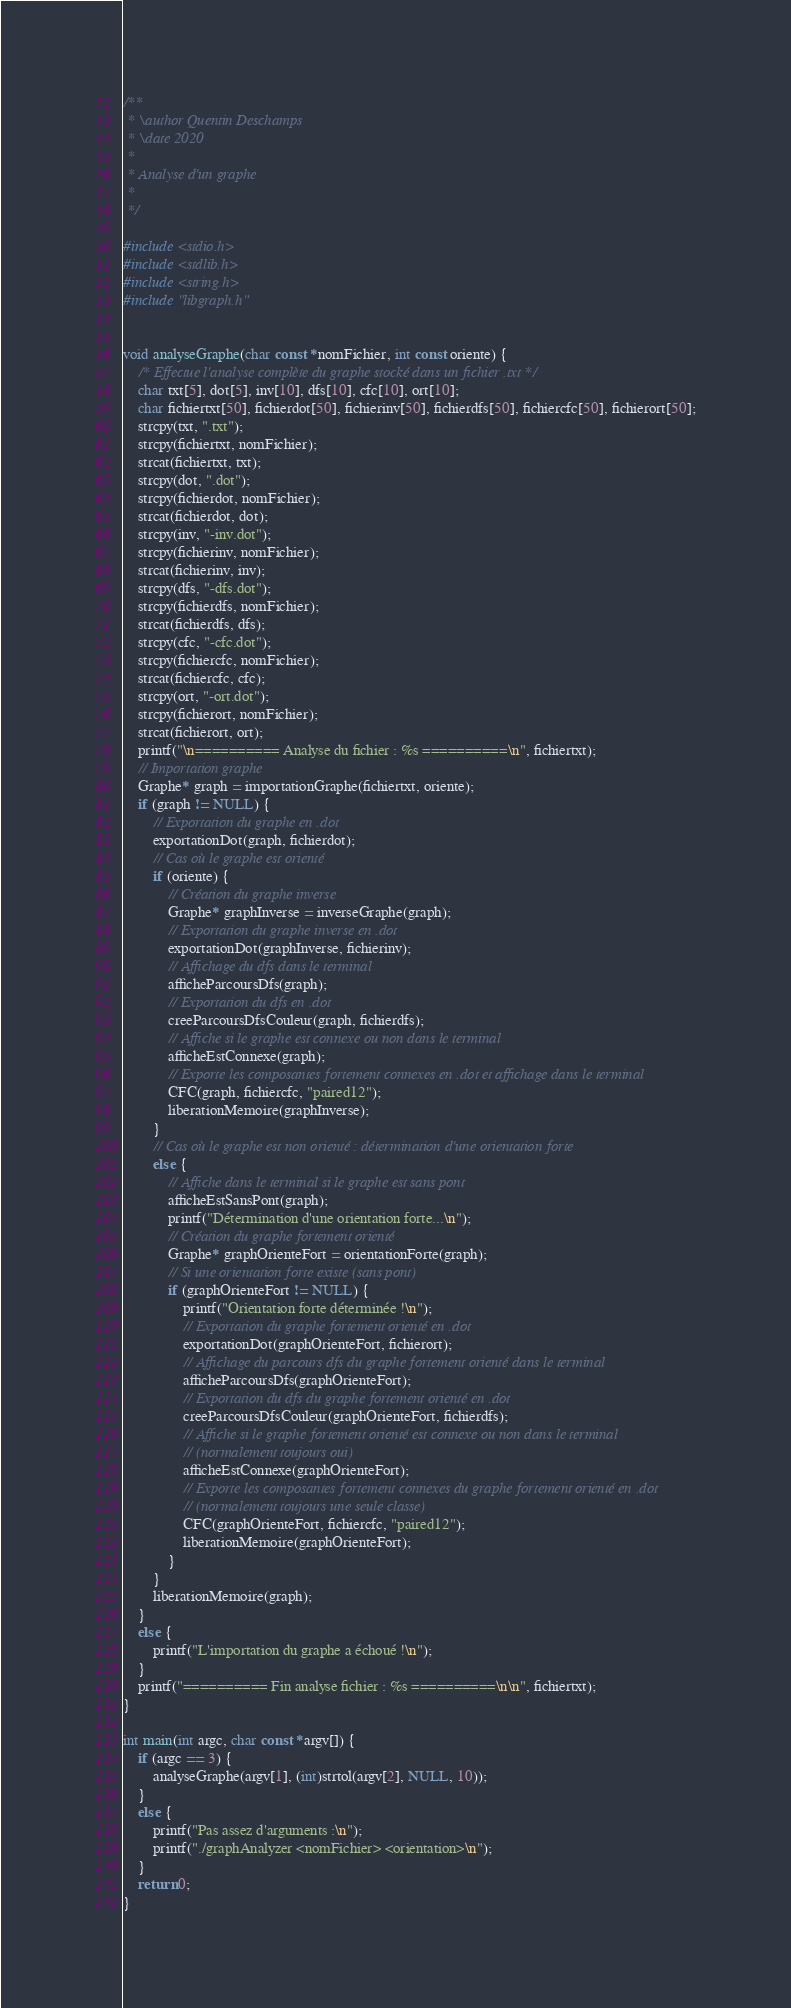Convert code to text. <code><loc_0><loc_0><loc_500><loc_500><_C_>/**
 * \author Quentin Deschamps
 * \date 2020
 *
 * Analyse d'un graphe
 *
 */

#include <stdio.h>
#include <stdlib.h>
#include <string.h>
#include "libgraph.h"


void analyseGraphe(char const *nomFichier, int const oriente) {
    /* Effectue l'analyse complète du graphe stocké dans un fichier .txt */
    char txt[5], dot[5], inv[10], dfs[10], cfc[10], ort[10];
    char fichiertxt[50], fichierdot[50], fichierinv[50], fichierdfs[50], fichiercfc[50], fichierort[50];
    strcpy(txt, ".txt");
    strcpy(fichiertxt, nomFichier);
    strcat(fichiertxt, txt);
    strcpy(dot, ".dot");
    strcpy(fichierdot, nomFichier);
    strcat(fichierdot, dot);
    strcpy(inv, "-inv.dot");
    strcpy(fichierinv, nomFichier);
    strcat(fichierinv, inv);
    strcpy(dfs, "-dfs.dot");
    strcpy(fichierdfs, nomFichier);
    strcat(fichierdfs, dfs);
    strcpy(cfc, "-cfc.dot");
    strcpy(fichiercfc, nomFichier);
    strcat(fichiercfc, cfc);
    strcpy(ort, "-ort.dot");
    strcpy(fichierort, nomFichier);
    strcat(fichierort, ort);
    printf("\n========== Analyse du fichier : %s ==========\n", fichiertxt);
    // Importation graphe
    Graphe* graph = importationGraphe(fichiertxt, oriente);
    if (graph != NULL) {
        // Exportation du graphe en .dot
        exportationDot(graph, fichierdot);
        // Cas où le graphe est orienté
        if (oriente) {
            // Création du graphe inverse
            Graphe* graphInverse = inverseGraphe(graph);
            // Exportation du graphe inverse en .dot
            exportationDot(graphInverse, fichierinv);
            // Affichage du dfs dans le terminal
            afficheParcoursDfs(graph);
            // Exportation du dfs en .dot
            creeParcoursDfsCouleur(graph, fichierdfs);
            // Affiche si le graphe est connexe ou non dans le terminal
            afficheEstConnexe(graph);
            // Exporte les composantes fortement connexes en .dot et affichage dans le terminal
            CFC(graph, fichiercfc, "paired12");
            liberationMemoire(graphInverse);
        }
        // Cas où le graphe est non orienté : détermination d'une orientation forte
        else {
            // Affiche dans le terminal si le graphe est sans pont
            afficheEstSansPont(graph);
            printf("Détermination d'une orientation forte...\n");
            // Création du graphe fortement orienté
            Graphe* graphOrienteFort = orientationForte(graph); 
            // Si une orientation forte existe (sans pont)
            if (graphOrienteFort != NULL) {
                printf("Orientation forte déterminée !\n");
                // Exportation du graphe fortement orienté en .dot
                exportationDot(graphOrienteFort, fichierort);
                // Affichage du parcours dfs du graphe fortement orienté dans le terminal
                afficheParcoursDfs(graphOrienteFort);
                // Exportation du dfs du graphe fortement orienté en .dot
                creeParcoursDfsCouleur(graphOrienteFort, fichierdfs);
                // Affiche si le graphe fortement orienté est connexe ou non dans le terminal
                // (normalement toujours oui)
                afficheEstConnexe(graphOrienteFort);
                // Exporte les composantes fortement connexes du graphe fortement orienté en .dot
                // (normalement toujours une seule classe)
                CFC(graphOrienteFort, fichiercfc, "paired12");
                liberationMemoire(graphOrienteFort);
            }
        }
        liberationMemoire(graph);
    }
    else {
        printf("L'importation du graphe a échoué !\n");
    }
    printf("========== Fin analyse fichier : %s ==========\n\n", fichiertxt);
}

int main(int argc, char const *argv[]) {
    if (argc == 3) {
        analyseGraphe(argv[1], (int)strtol(argv[2], NULL, 10));
    }
    else {
        printf("Pas assez d'arguments :\n");
        printf("./graphAnalyzer <nomFichier> <orientation>\n");
    }
    return 0;
}
</code> 